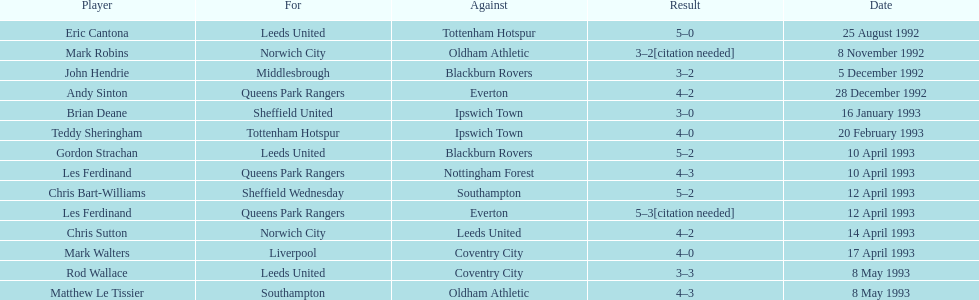State the members for tottenham hotspur. Teddy Sheringham. 